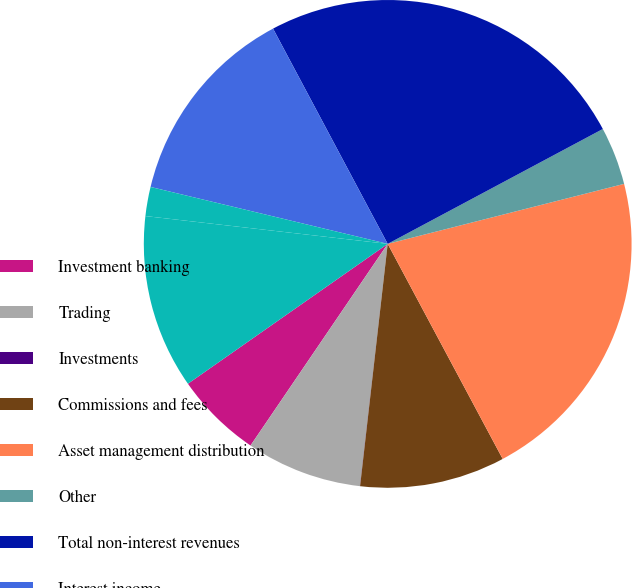<chart> <loc_0><loc_0><loc_500><loc_500><pie_chart><fcel>Investment banking<fcel>Trading<fcel>Investments<fcel>Commissions and fees<fcel>Asset management distribution<fcel>Other<fcel>Total non-interest revenues<fcel>Interest income<fcel>Interest expense<fcel>Net interest<nl><fcel>5.77%<fcel>7.69%<fcel>0.01%<fcel>9.62%<fcel>21.14%<fcel>3.85%<fcel>24.98%<fcel>13.46%<fcel>1.93%<fcel>11.54%<nl></chart> 